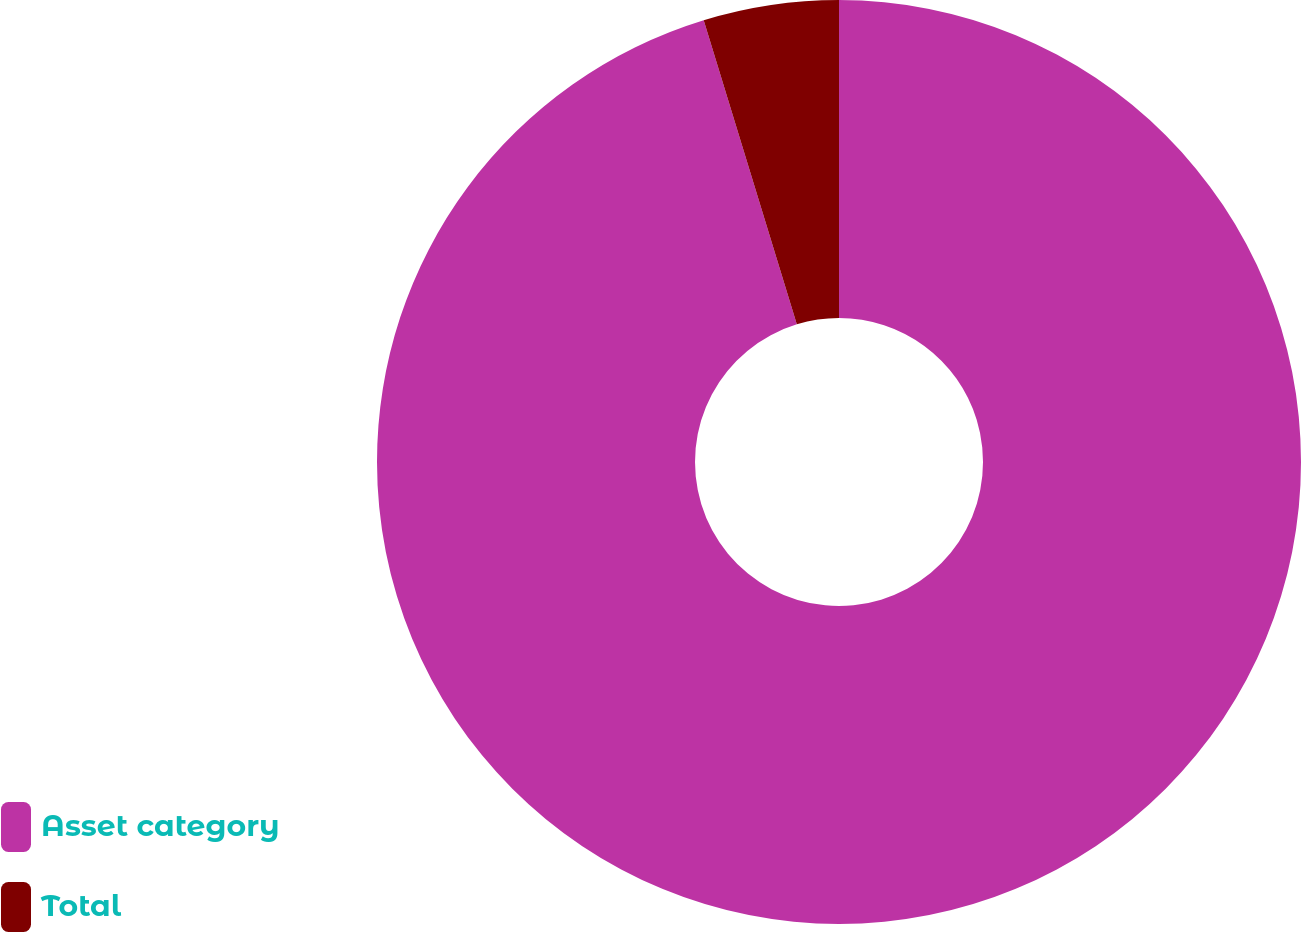Convert chart to OTSL. <chart><loc_0><loc_0><loc_500><loc_500><pie_chart><fcel>Asset category<fcel>Total<nl><fcel>95.27%<fcel>4.73%<nl></chart> 